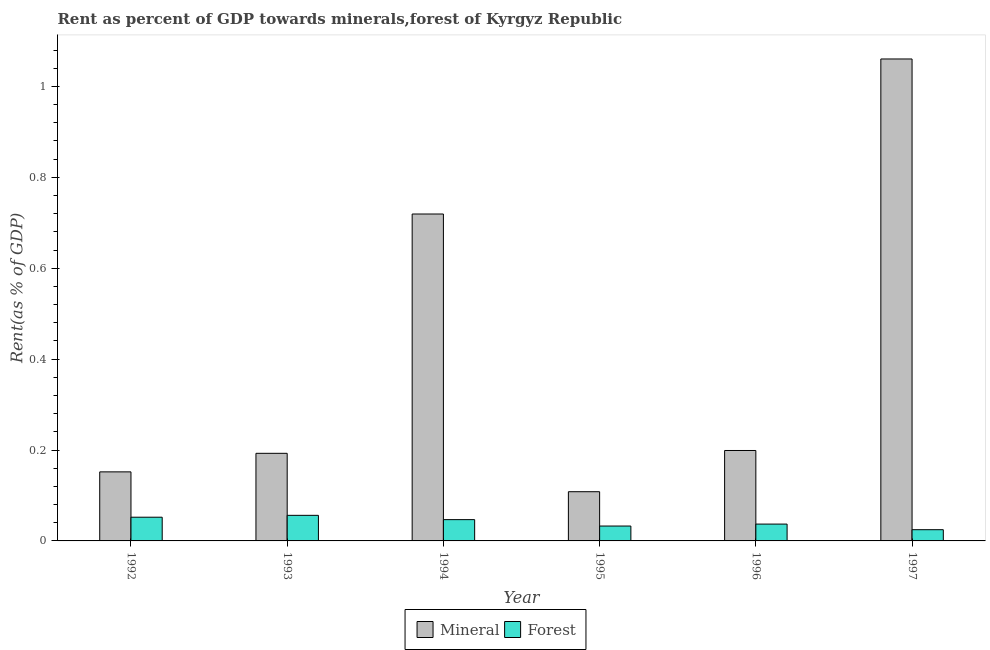How many different coloured bars are there?
Provide a succinct answer. 2. Are the number of bars on each tick of the X-axis equal?
Provide a succinct answer. Yes. How many bars are there on the 4th tick from the left?
Provide a short and direct response. 2. In how many cases, is the number of bars for a given year not equal to the number of legend labels?
Your answer should be very brief. 0. What is the forest rent in 1994?
Keep it short and to the point. 0.05. Across all years, what is the maximum mineral rent?
Offer a terse response. 1.06. Across all years, what is the minimum forest rent?
Your answer should be very brief. 0.02. In which year was the forest rent maximum?
Provide a short and direct response. 1993. What is the total mineral rent in the graph?
Provide a short and direct response. 2.43. What is the difference between the forest rent in 1994 and that in 1996?
Provide a succinct answer. 0.01. What is the difference between the forest rent in 1993 and the mineral rent in 1996?
Provide a succinct answer. 0.02. What is the average mineral rent per year?
Keep it short and to the point. 0.41. In how many years, is the mineral rent greater than 0.8 %?
Make the answer very short. 1. What is the ratio of the mineral rent in 1993 to that in 1997?
Your answer should be very brief. 0.18. What is the difference between the highest and the second highest mineral rent?
Keep it short and to the point. 0.34. What is the difference between the highest and the lowest mineral rent?
Your answer should be compact. 0.95. In how many years, is the mineral rent greater than the average mineral rent taken over all years?
Provide a succinct answer. 2. What does the 1st bar from the left in 1995 represents?
Provide a succinct answer. Mineral. What does the 1st bar from the right in 1996 represents?
Your response must be concise. Forest. How many bars are there?
Provide a short and direct response. 12. How many years are there in the graph?
Offer a very short reply. 6. Where does the legend appear in the graph?
Keep it short and to the point. Bottom center. How are the legend labels stacked?
Provide a short and direct response. Horizontal. What is the title of the graph?
Provide a short and direct response. Rent as percent of GDP towards minerals,forest of Kyrgyz Republic. Does "Revenue" appear as one of the legend labels in the graph?
Offer a very short reply. No. What is the label or title of the X-axis?
Provide a short and direct response. Year. What is the label or title of the Y-axis?
Give a very brief answer. Rent(as % of GDP). What is the Rent(as % of GDP) of Mineral in 1992?
Make the answer very short. 0.15. What is the Rent(as % of GDP) in Forest in 1992?
Ensure brevity in your answer.  0.05. What is the Rent(as % of GDP) of Mineral in 1993?
Your answer should be compact. 0.19. What is the Rent(as % of GDP) of Forest in 1993?
Your response must be concise. 0.06. What is the Rent(as % of GDP) in Mineral in 1994?
Your answer should be very brief. 0.72. What is the Rent(as % of GDP) in Forest in 1994?
Offer a terse response. 0.05. What is the Rent(as % of GDP) in Mineral in 1995?
Ensure brevity in your answer.  0.11. What is the Rent(as % of GDP) in Forest in 1995?
Offer a terse response. 0.03. What is the Rent(as % of GDP) in Mineral in 1996?
Ensure brevity in your answer.  0.2. What is the Rent(as % of GDP) of Forest in 1996?
Your response must be concise. 0.04. What is the Rent(as % of GDP) of Mineral in 1997?
Provide a succinct answer. 1.06. What is the Rent(as % of GDP) of Forest in 1997?
Give a very brief answer. 0.02. Across all years, what is the maximum Rent(as % of GDP) in Mineral?
Make the answer very short. 1.06. Across all years, what is the maximum Rent(as % of GDP) of Forest?
Give a very brief answer. 0.06. Across all years, what is the minimum Rent(as % of GDP) in Mineral?
Provide a succinct answer. 0.11. Across all years, what is the minimum Rent(as % of GDP) in Forest?
Make the answer very short. 0.02. What is the total Rent(as % of GDP) of Mineral in the graph?
Provide a short and direct response. 2.43. What is the total Rent(as % of GDP) in Forest in the graph?
Provide a short and direct response. 0.25. What is the difference between the Rent(as % of GDP) in Mineral in 1992 and that in 1993?
Provide a succinct answer. -0.04. What is the difference between the Rent(as % of GDP) of Forest in 1992 and that in 1993?
Ensure brevity in your answer.  -0. What is the difference between the Rent(as % of GDP) of Mineral in 1992 and that in 1994?
Your answer should be very brief. -0.57. What is the difference between the Rent(as % of GDP) in Forest in 1992 and that in 1994?
Offer a terse response. 0.01. What is the difference between the Rent(as % of GDP) of Mineral in 1992 and that in 1995?
Your response must be concise. 0.04. What is the difference between the Rent(as % of GDP) in Forest in 1992 and that in 1995?
Ensure brevity in your answer.  0.02. What is the difference between the Rent(as % of GDP) in Mineral in 1992 and that in 1996?
Provide a short and direct response. -0.05. What is the difference between the Rent(as % of GDP) of Forest in 1992 and that in 1996?
Provide a succinct answer. 0.02. What is the difference between the Rent(as % of GDP) of Mineral in 1992 and that in 1997?
Keep it short and to the point. -0.91. What is the difference between the Rent(as % of GDP) of Forest in 1992 and that in 1997?
Make the answer very short. 0.03. What is the difference between the Rent(as % of GDP) in Mineral in 1993 and that in 1994?
Give a very brief answer. -0.53. What is the difference between the Rent(as % of GDP) of Forest in 1993 and that in 1994?
Your response must be concise. 0.01. What is the difference between the Rent(as % of GDP) of Mineral in 1993 and that in 1995?
Your answer should be very brief. 0.08. What is the difference between the Rent(as % of GDP) of Forest in 1993 and that in 1995?
Give a very brief answer. 0.02. What is the difference between the Rent(as % of GDP) of Mineral in 1993 and that in 1996?
Keep it short and to the point. -0.01. What is the difference between the Rent(as % of GDP) in Forest in 1993 and that in 1996?
Your answer should be very brief. 0.02. What is the difference between the Rent(as % of GDP) in Mineral in 1993 and that in 1997?
Your answer should be compact. -0.87. What is the difference between the Rent(as % of GDP) in Forest in 1993 and that in 1997?
Ensure brevity in your answer.  0.03. What is the difference between the Rent(as % of GDP) of Mineral in 1994 and that in 1995?
Provide a short and direct response. 0.61. What is the difference between the Rent(as % of GDP) in Forest in 1994 and that in 1995?
Offer a very short reply. 0.01. What is the difference between the Rent(as % of GDP) in Mineral in 1994 and that in 1996?
Provide a short and direct response. 0.52. What is the difference between the Rent(as % of GDP) of Forest in 1994 and that in 1996?
Your answer should be very brief. 0.01. What is the difference between the Rent(as % of GDP) in Mineral in 1994 and that in 1997?
Your answer should be compact. -0.34. What is the difference between the Rent(as % of GDP) of Forest in 1994 and that in 1997?
Give a very brief answer. 0.02. What is the difference between the Rent(as % of GDP) of Mineral in 1995 and that in 1996?
Make the answer very short. -0.09. What is the difference between the Rent(as % of GDP) in Forest in 1995 and that in 1996?
Keep it short and to the point. -0. What is the difference between the Rent(as % of GDP) of Mineral in 1995 and that in 1997?
Make the answer very short. -0.95. What is the difference between the Rent(as % of GDP) of Forest in 1995 and that in 1997?
Make the answer very short. 0.01. What is the difference between the Rent(as % of GDP) in Mineral in 1996 and that in 1997?
Provide a short and direct response. -0.86. What is the difference between the Rent(as % of GDP) of Forest in 1996 and that in 1997?
Give a very brief answer. 0.01. What is the difference between the Rent(as % of GDP) in Mineral in 1992 and the Rent(as % of GDP) in Forest in 1993?
Provide a succinct answer. 0.1. What is the difference between the Rent(as % of GDP) in Mineral in 1992 and the Rent(as % of GDP) in Forest in 1994?
Your answer should be compact. 0.11. What is the difference between the Rent(as % of GDP) of Mineral in 1992 and the Rent(as % of GDP) of Forest in 1995?
Offer a terse response. 0.12. What is the difference between the Rent(as % of GDP) of Mineral in 1992 and the Rent(as % of GDP) of Forest in 1996?
Your answer should be compact. 0.11. What is the difference between the Rent(as % of GDP) in Mineral in 1992 and the Rent(as % of GDP) in Forest in 1997?
Give a very brief answer. 0.13. What is the difference between the Rent(as % of GDP) in Mineral in 1993 and the Rent(as % of GDP) in Forest in 1994?
Your response must be concise. 0.15. What is the difference between the Rent(as % of GDP) of Mineral in 1993 and the Rent(as % of GDP) of Forest in 1995?
Keep it short and to the point. 0.16. What is the difference between the Rent(as % of GDP) of Mineral in 1993 and the Rent(as % of GDP) of Forest in 1996?
Give a very brief answer. 0.16. What is the difference between the Rent(as % of GDP) in Mineral in 1993 and the Rent(as % of GDP) in Forest in 1997?
Give a very brief answer. 0.17. What is the difference between the Rent(as % of GDP) of Mineral in 1994 and the Rent(as % of GDP) of Forest in 1995?
Your response must be concise. 0.69. What is the difference between the Rent(as % of GDP) of Mineral in 1994 and the Rent(as % of GDP) of Forest in 1996?
Offer a terse response. 0.68. What is the difference between the Rent(as % of GDP) of Mineral in 1994 and the Rent(as % of GDP) of Forest in 1997?
Your answer should be very brief. 0.69. What is the difference between the Rent(as % of GDP) of Mineral in 1995 and the Rent(as % of GDP) of Forest in 1996?
Provide a short and direct response. 0.07. What is the difference between the Rent(as % of GDP) in Mineral in 1995 and the Rent(as % of GDP) in Forest in 1997?
Offer a terse response. 0.08. What is the difference between the Rent(as % of GDP) of Mineral in 1996 and the Rent(as % of GDP) of Forest in 1997?
Provide a short and direct response. 0.17. What is the average Rent(as % of GDP) of Mineral per year?
Ensure brevity in your answer.  0.41. What is the average Rent(as % of GDP) in Forest per year?
Offer a very short reply. 0.04. In the year 1992, what is the difference between the Rent(as % of GDP) in Mineral and Rent(as % of GDP) in Forest?
Your answer should be compact. 0.1. In the year 1993, what is the difference between the Rent(as % of GDP) in Mineral and Rent(as % of GDP) in Forest?
Your answer should be compact. 0.14. In the year 1994, what is the difference between the Rent(as % of GDP) of Mineral and Rent(as % of GDP) of Forest?
Offer a very short reply. 0.67. In the year 1995, what is the difference between the Rent(as % of GDP) in Mineral and Rent(as % of GDP) in Forest?
Give a very brief answer. 0.08. In the year 1996, what is the difference between the Rent(as % of GDP) in Mineral and Rent(as % of GDP) in Forest?
Offer a very short reply. 0.16. In the year 1997, what is the difference between the Rent(as % of GDP) of Mineral and Rent(as % of GDP) of Forest?
Ensure brevity in your answer.  1.04. What is the ratio of the Rent(as % of GDP) of Mineral in 1992 to that in 1993?
Your answer should be very brief. 0.79. What is the ratio of the Rent(as % of GDP) in Forest in 1992 to that in 1993?
Your answer should be compact. 0.93. What is the ratio of the Rent(as % of GDP) of Mineral in 1992 to that in 1994?
Your answer should be very brief. 0.21. What is the ratio of the Rent(as % of GDP) in Forest in 1992 to that in 1994?
Offer a terse response. 1.11. What is the ratio of the Rent(as % of GDP) in Mineral in 1992 to that in 1995?
Ensure brevity in your answer.  1.4. What is the ratio of the Rent(as % of GDP) of Forest in 1992 to that in 1995?
Your answer should be compact. 1.59. What is the ratio of the Rent(as % of GDP) of Mineral in 1992 to that in 1996?
Your response must be concise. 0.76. What is the ratio of the Rent(as % of GDP) in Forest in 1992 to that in 1996?
Provide a succinct answer. 1.41. What is the ratio of the Rent(as % of GDP) in Mineral in 1992 to that in 1997?
Give a very brief answer. 0.14. What is the ratio of the Rent(as % of GDP) of Forest in 1992 to that in 1997?
Your answer should be compact. 2.11. What is the ratio of the Rent(as % of GDP) of Mineral in 1993 to that in 1994?
Keep it short and to the point. 0.27. What is the ratio of the Rent(as % of GDP) of Forest in 1993 to that in 1994?
Provide a short and direct response. 1.2. What is the ratio of the Rent(as % of GDP) of Mineral in 1993 to that in 1995?
Keep it short and to the point. 1.78. What is the ratio of the Rent(as % of GDP) of Forest in 1993 to that in 1995?
Give a very brief answer. 1.72. What is the ratio of the Rent(as % of GDP) of Mineral in 1993 to that in 1996?
Offer a very short reply. 0.97. What is the ratio of the Rent(as % of GDP) in Forest in 1993 to that in 1996?
Make the answer very short. 1.52. What is the ratio of the Rent(as % of GDP) of Mineral in 1993 to that in 1997?
Provide a short and direct response. 0.18. What is the ratio of the Rent(as % of GDP) of Forest in 1993 to that in 1997?
Offer a terse response. 2.28. What is the ratio of the Rent(as % of GDP) of Mineral in 1994 to that in 1995?
Ensure brevity in your answer.  6.64. What is the ratio of the Rent(as % of GDP) of Forest in 1994 to that in 1995?
Give a very brief answer. 1.43. What is the ratio of the Rent(as % of GDP) of Mineral in 1994 to that in 1996?
Provide a short and direct response. 3.61. What is the ratio of the Rent(as % of GDP) in Forest in 1994 to that in 1996?
Keep it short and to the point. 1.26. What is the ratio of the Rent(as % of GDP) in Mineral in 1994 to that in 1997?
Make the answer very short. 0.68. What is the ratio of the Rent(as % of GDP) of Forest in 1994 to that in 1997?
Offer a terse response. 1.9. What is the ratio of the Rent(as % of GDP) of Mineral in 1995 to that in 1996?
Offer a very short reply. 0.54. What is the ratio of the Rent(as % of GDP) of Forest in 1995 to that in 1996?
Make the answer very short. 0.88. What is the ratio of the Rent(as % of GDP) in Mineral in 1995 to that in 1997?
Your answer should be compact. 0.1. What is the ratio of the Rent(as % of GDP) in Forest in 1995 to that in 1997?
Your answer should be very brief. 1.33. What is the ratio of the Rent(as % of GDP) of Mineral in 1996 to that in 1997?
Your response must be concise. 0.19. What is the ratio of the Rent(as % of GDP) in Forest in 1996 to that in 1997?
Offer a terse response. 1.5. What is the difference between the highest and the second highest Rent(as % of GDP) of Mineral?
Make the answer very short. 0.34. What is the difference between the highest and the second highest Rent(as % of GDP) in Forest?
Keep it short and to the point. 0. What is the difference between the highest and the lowest Rent(as % of GDP) of Mineral?
Provide a succinct answer. 0.95. What is the difference between the highest and the lowest Rent(as % of GDP) in Forest?
Keep it short and to the point. 0.03. 